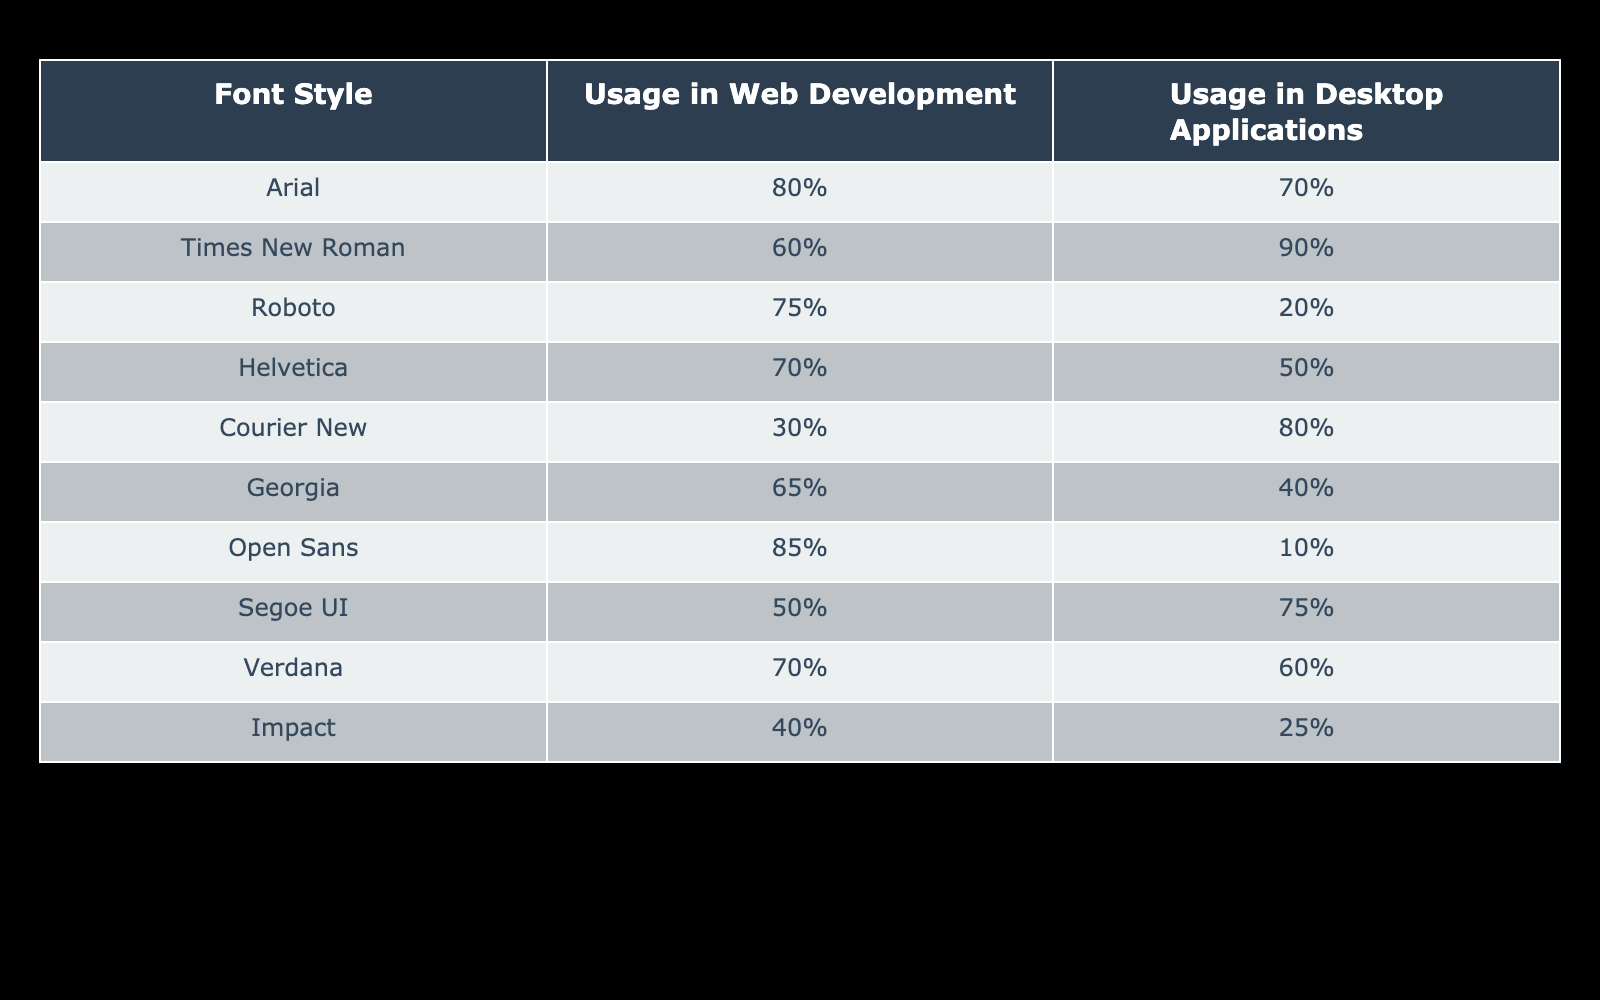What is the usage percentage of Arial in web development? The usage percentage of Arial in web development can be found directly in the table under the "Usage in Web Development" column next to "Arial", which shows 80%.
Answer: 80% Which font style has the highest usage in web development? To find the font style with the highest usage in web development, we can compare all the usage percentages in that column. The highest value is 85% for Open Sans.
Answer: Open Sans What is the difference in percentage usage of Times New Roman between desktop applications and web development? To find the difference in usage for Times New Roman, we look at both columns: the desktop application usage is 90% and web development usage is 60%. The difference is calculated as 90% - 60% = 30%.
Answer: 30% Is Roboto used more in web development than in desktop applications? Checking the usage percentages, Roboto has 75% for web development and only 20% for desktop applications. Thus, the statement is true.
Answer: Yes What is the average usage percentage of fonts in desktop applications? To find the average, we sum up the percentages of all fonts in desktop applications and then divide by the number of fonts. The sum is 70 + 90 + 20 + 50 + 80 + 40 + 10 + 75 + 60 + 25 = 420. There are 10 entries, so the average is 420/10 = 42%.
Answer: 42% Which font has the least usage in web development, and what is its percentage? We need to look through the "Usage in Web Development" column to find the lowest value. Upon reviewing, Courier New has the least usage at 30%.
Answer: Courier New, 30% How many fonts have a higher usage percentage in desktop applications than in web development? We will check each pair of usage percentages. From the table, Segoe UI, Times New Roman, and Courier New have higher usage in desktop applications than in web development. This amounts to three fonts.
Answer: 3 Is Georgia more commonly used in web development than Verdana? Checking the two values, Georgia has 65% in web development, and Verdana is at 70%. Since 65% is less than 70%, this statement is false.
Answer: No What is the combined usage percentage of Arial and Roboto in web development? To find the combined usage percentage, we need to add the percentages for Arial (80%) and Roboto (75%). So, 80% + 75% = 155%.
Answer: 155% 